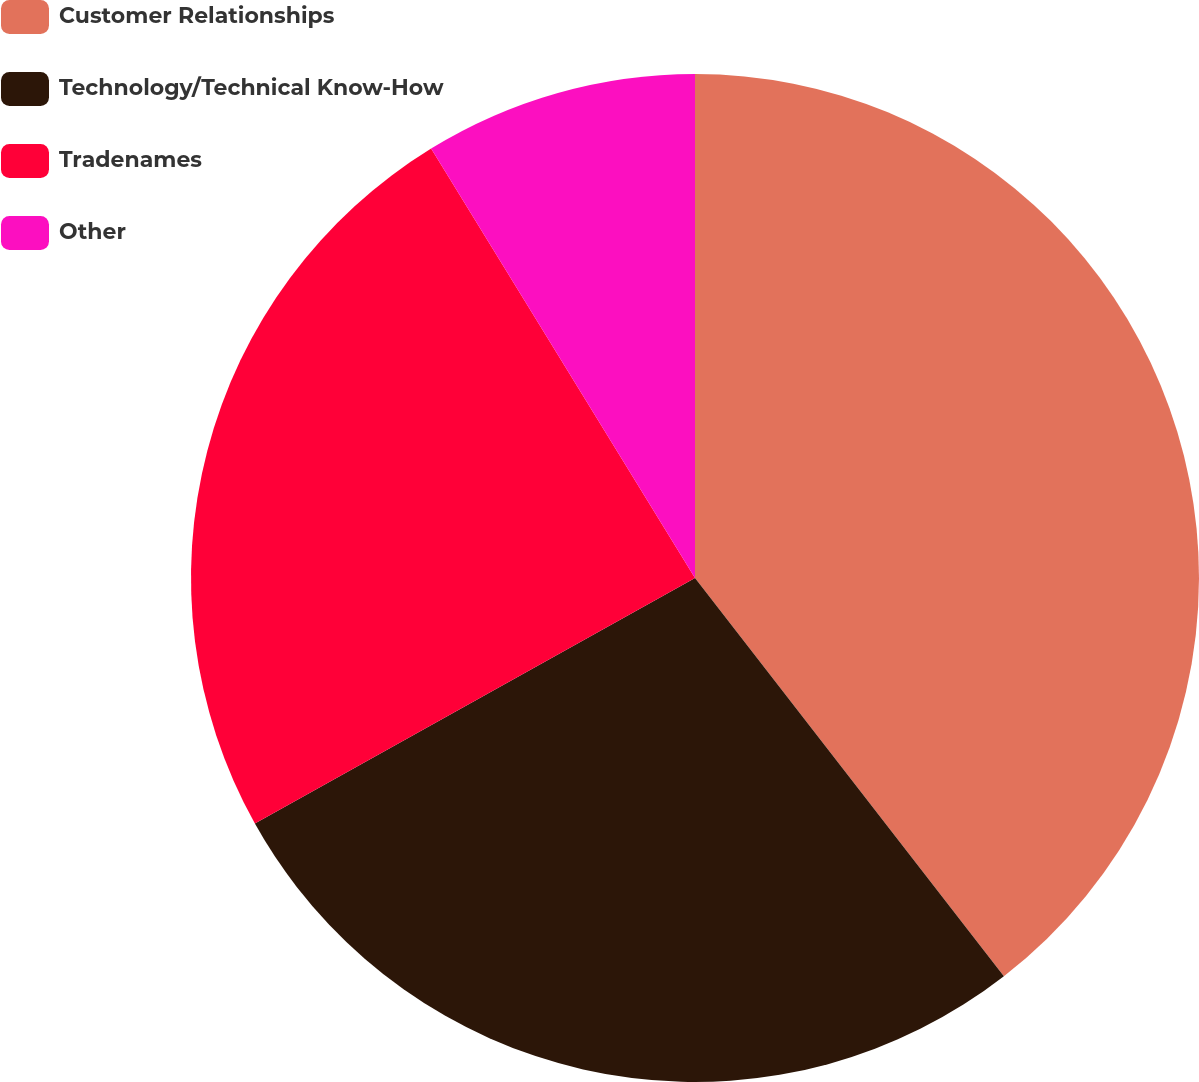<chart> <loc_0><loc_0><loc_500><loc_500><pie_chart><fcel>Customer Relationships<fcel>Technology/Technical Know-How<fcel>Tradenames<fcel>Other<nl><fcel>39.5%<fcel>27.4%<fcel>24.33%<fcel>8.77%<nl></chart> 